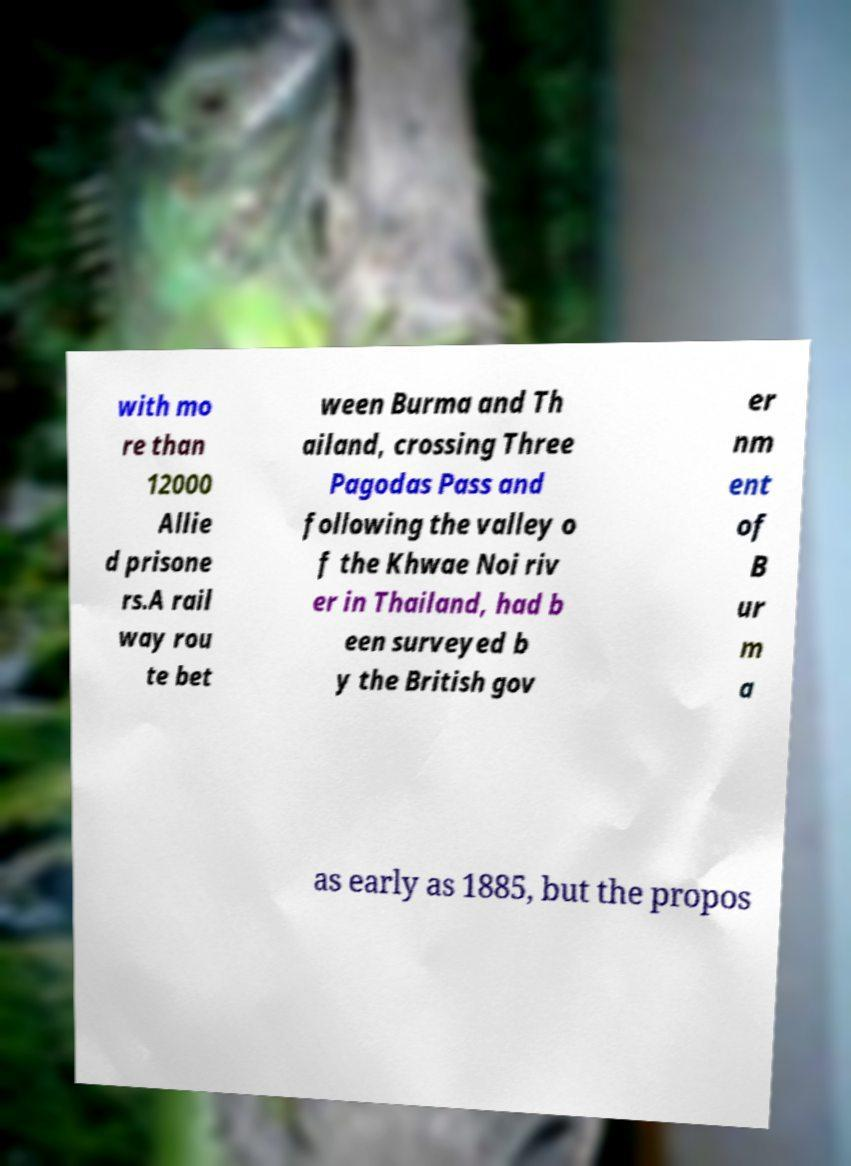Could you extract and type out the text from this image? with mo re than 12000 Allie d prisone rs.A rail way rou te bet ween Burma and Th ailand, crossing Three Pagodas Pass and following the valley o f the Khwae Noi riv er in Thailand, had b een surveyed b y the British gov er nm ent of B ur m a as early as 1885, but the propos 